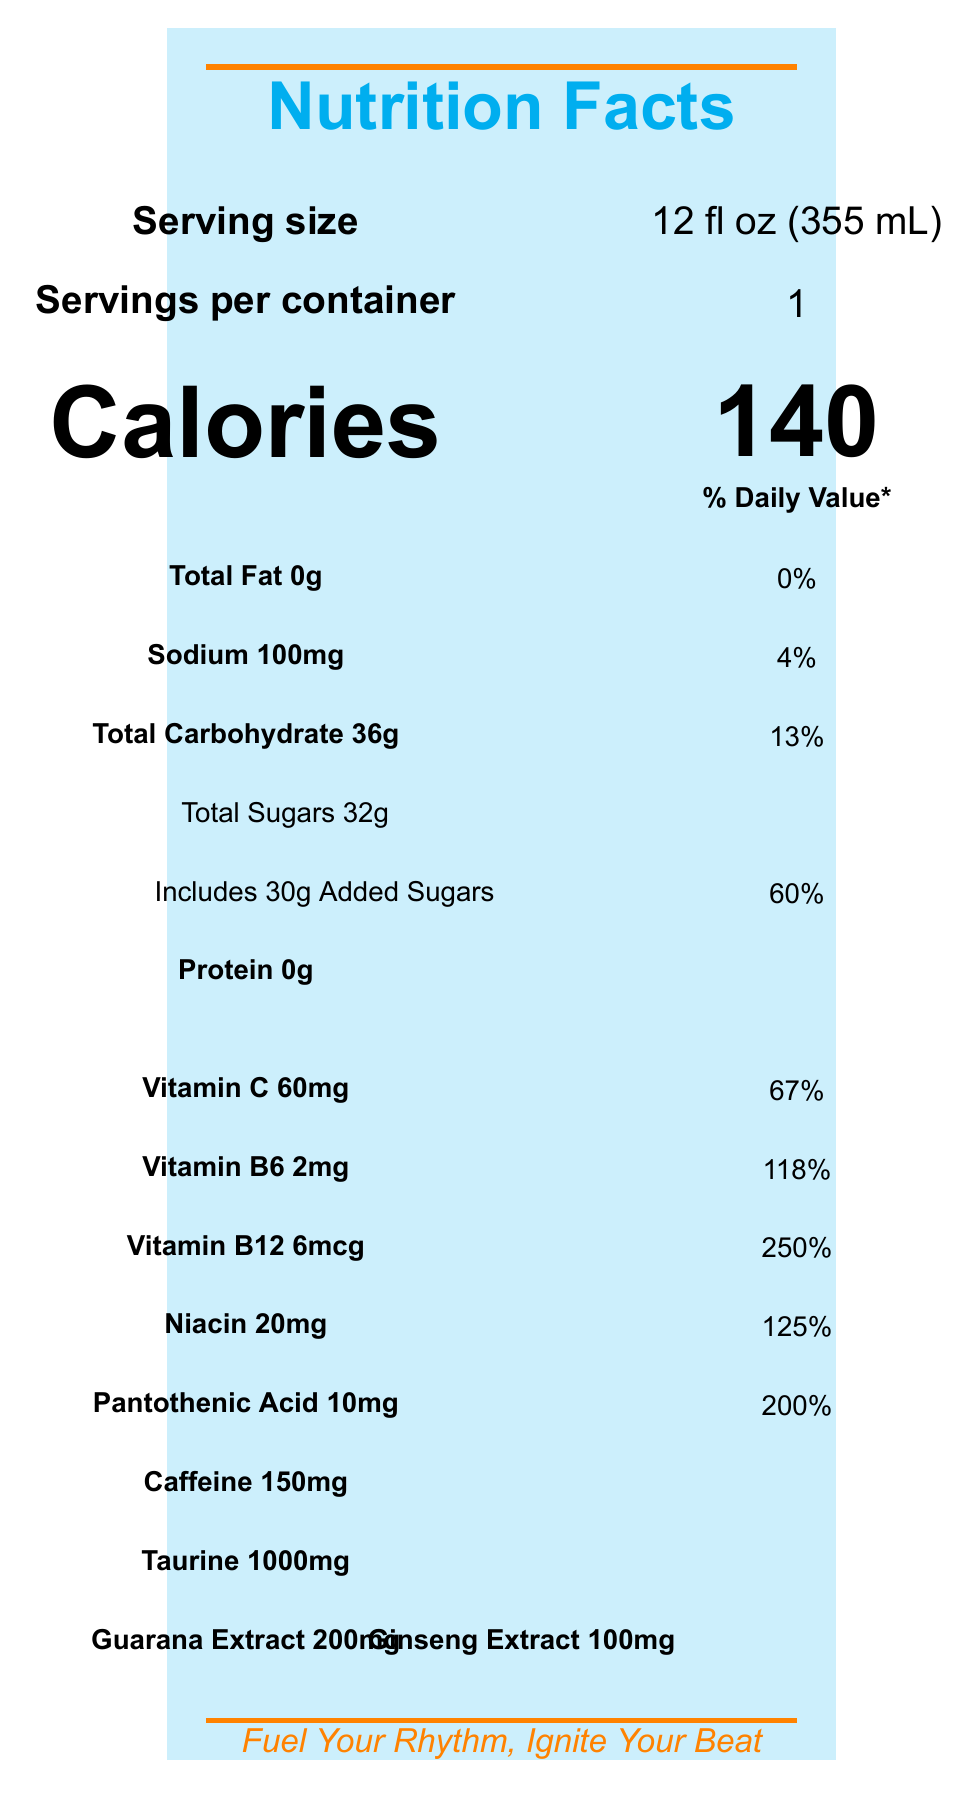what is the serving size of Ritmo Tropical Energy? The serving size is listed at the top of the document as "12 fl oz (355 mL)".
Answer: 12 fl oz (355 mL) how many calories are in one serving of Ritmo Tropical Energy? The document states that there are 140 calories per serving, as shown in large font in the calorie information section.
Answer: 140 what percentage of the daily value of Vitamin C does Ritmo Tropical Energy provide? The nutrition facts section lists Vitamin C as providing 67% of the daily value.
Answer: 67% how much sodium is in one serving of Ritmo Tropical Energy? The sodium content is stated as "100mg" in the nutrient table.
Answer: 100mg how many grams of total carbohydrates are present in one serving? The total carbohydrate content is "36g", which can be found in the nutrient table section.
Answer: 36g what are the main ingredients in Ritmo Tropical Energy? A. Carbonated Water, Sugar, Citric Acid B. Carbonated Water, Sugar, Taurine C. Carbonated Water, Taurine, Ginseng Extract D. Carbonated Water, Sugar, Natural Flavors The primary ingredients listed under the ingredients section are Carbonated Water, Sugar, Citric Acid.
Answer: A. Carbonated Water, Sugar, Citric Acid which vitamin has the highest daily value percentage in Ritmo Tropical Energy? A. Vitamin C B. Vitamin B6 C. Vitamin B12 D. Niacin Vitamin B12 has the highest daily value percentage at 250%, as detailed in the vitamin table.
Answer: C. Vitamin B12 does Ritmo Tropical Energy contain any protein? The nutrient table indicates that the protein content is "0g".
Answer: No can an individual allergic to soy safely consume Ritmo Tropical Energy? The allergen info states that it is produced in a facility that also processes soy products.
Answer: No provide a summary of the main idea of the nutrition facts label for Ritmo Tropical Energy. The summary encapsulates the key details about calories, ingredients, allergen information, and the special Reggaeton-themed marketing strategy.
Answer: Ritmo Tropical Energy is a tropical fruit-flavored energy drink that provides 140 calories per serving with notable amounts of added sugars and vitamins, significant caffeine content, and production in a facility that processes soy and milk products. Featuring Reggaeton-inspired flavors, the drink includes a tagline "Fuel Your Rhythm, Ignite Your Beat" and offers exclusive Reggaeton tracks through a purchase. how much Taurine does Ritmo Tropical Energy contain? The document lists Taurine content as "1000mg" in the section detailing other ingredients.
Answer: 1000mg which artist is featured in the limited-edition can design of Ritmo Tropical Energy? The document states that the limited-edition can design features artwork by renowned Reggaeton artist J Balvin.
Answer: J Balvin is there any information about the fruit ingredients used for the flavors in Ritmo Tropical Energy? The document mentions the flavors (Mango Passion, Pineapple Coconut, Guava Lime) but does not specify the exact fruit ingredients used.
Answer: Not enough information 